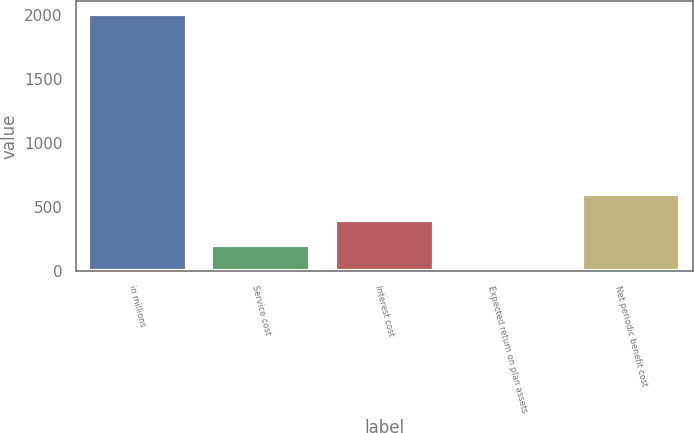Convert chart to OTSL. <chart><loc_0><loc_0><loc_500><loc_500><bar_chart><fcel>in millions<fcel>Service cost<fcel>Interest cost<fcel>Expected return on plan assets<fcel>Net periodic benefit cost<nl><fcel>2010<fcel>201.36<fcel>402.32<fcel>0.4<fcel>603.28<nl></chart> 